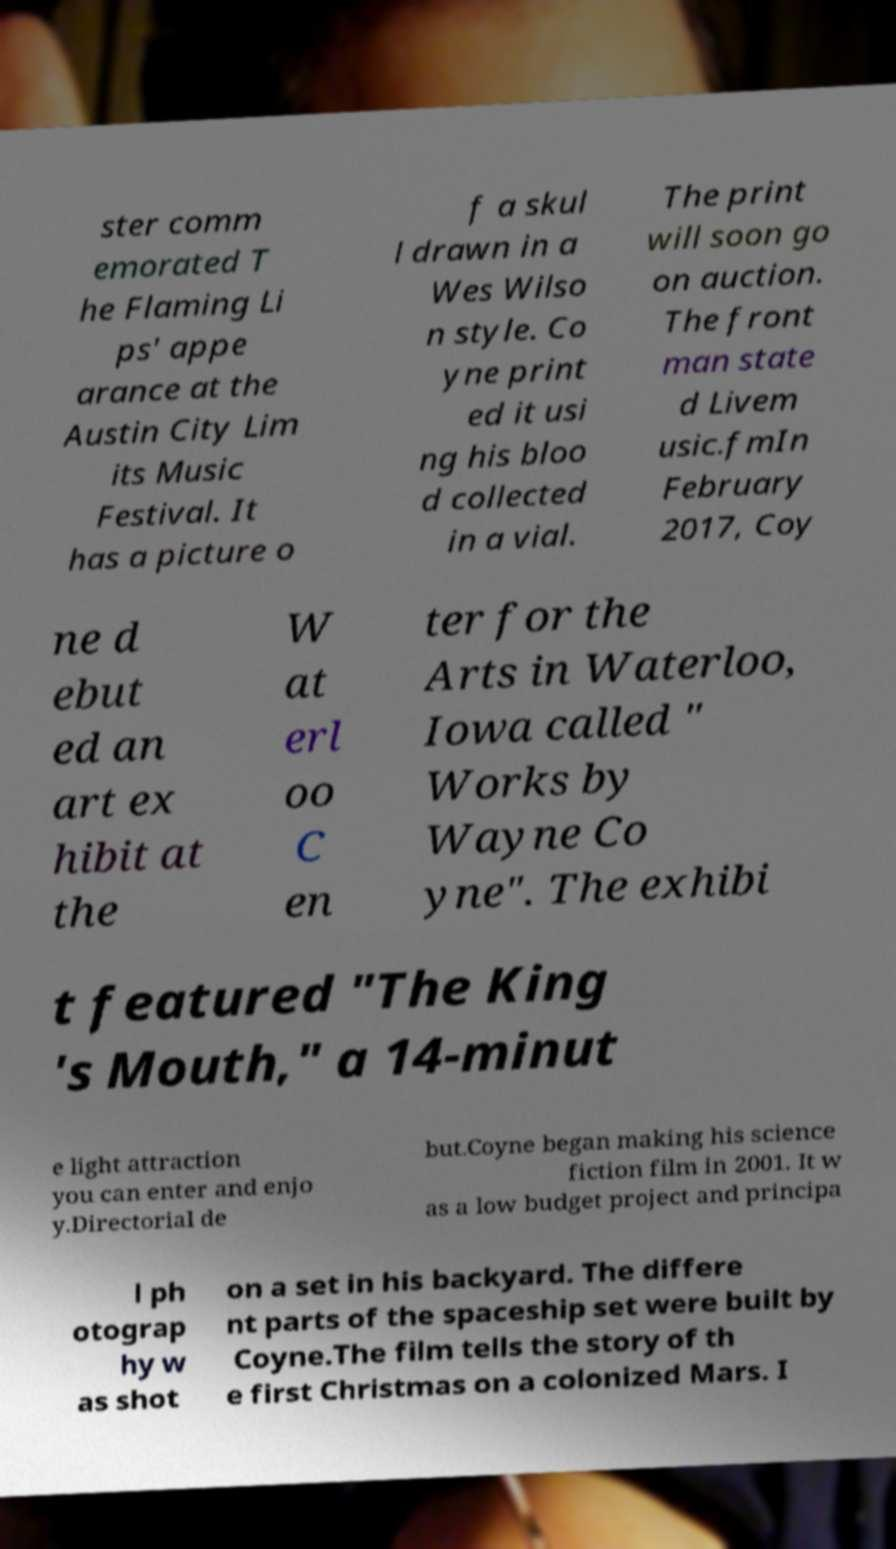I need the written content from this picture converted into text. Can you do that? ster comm emorated T he Flaming Li ps' appe arance at the Austin City Lim its Music Festival. It has a picture o f a skul l drawn in a Wes Wilso n style. Co yne print ed it usi ng his bloo d collected in a vial. The print will soon go on auction. The front man state d Livem usic.fmIn February 2017, Coy ne d ebut ed an art ex hibit at the W at erl oo C en ter for the Arts in Waterloo, Iowa called " Works by Wayne Co yne". The exhibi t featured "The King 's Mouth," a 14-minut e light attraction you can enter and enjo y.Directorial de but.Coyne began making his science fiction film in 2001. It w as a low budget project and principa l ph otograp hy w as shot on a set in his backyard. The differe nt parts of the spaceship set were built by Coyne.The film tells the story of th e first Christmas on a colonized Mars. I 